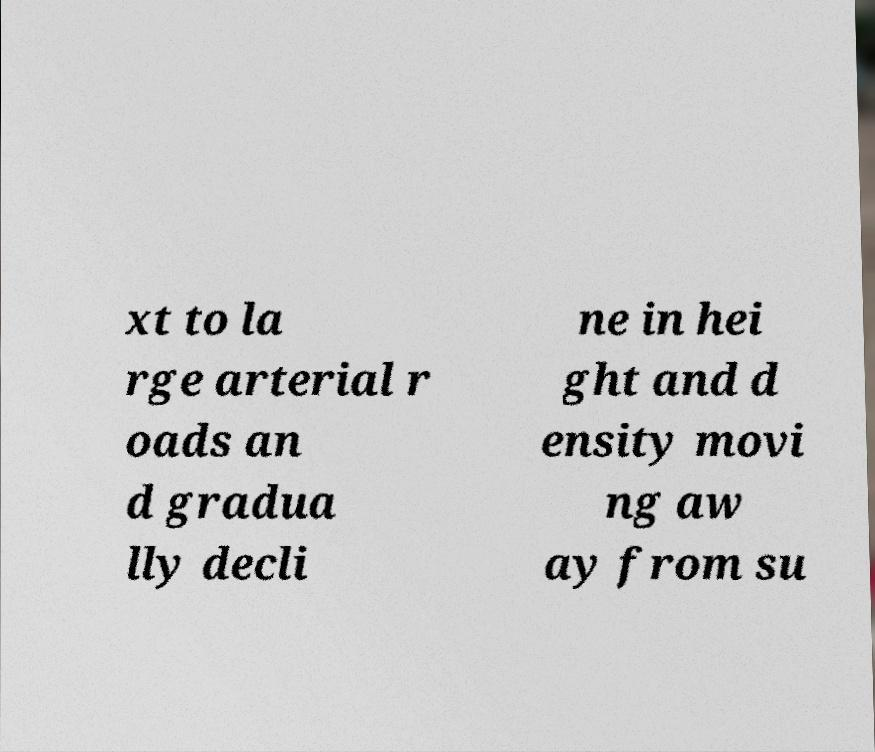Can you read and provide the text displayed in the image?This photo seems to have some interesting text. Can you extract and type it out for me? xt to la rge arterial r oads an d gradua lly decli ne in hei ght and d ensity movi ng aw ay from su 